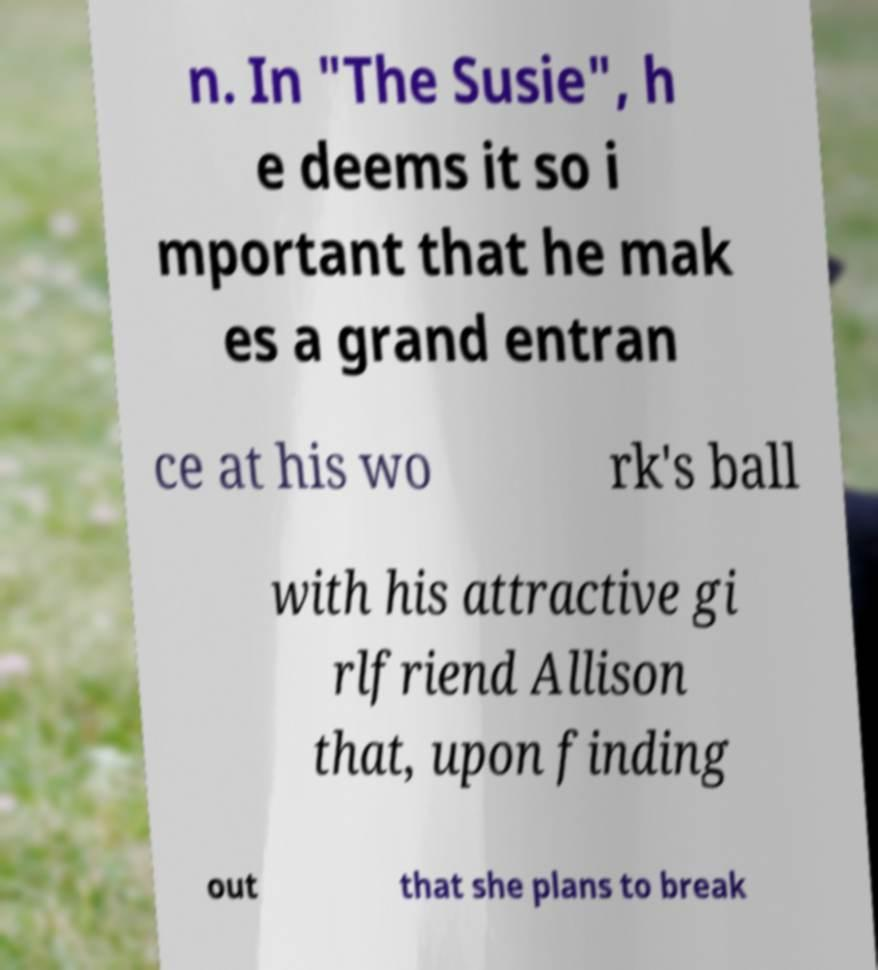There's text embedded in this image that I need extracted. Can you transcribe it verbatim? n. In "The Susie", h e deems it so i mportant that he mak es a grand entran ce at his wo rk's ball with his attractive gi rlfriend Allison that, upon finding out that she plans to break 